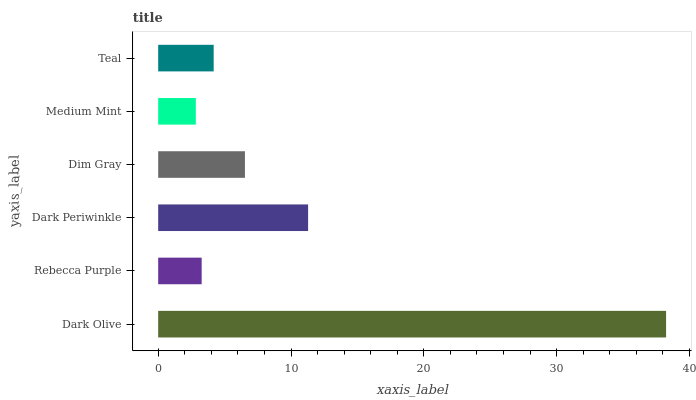Is Medium Mint the minimum?
Answer yes or no. Yes. Is Dark Olive the maximum?
Answer yes or no. Yes. Is Rebecca Purple the minimum?
Answer yes or no. No. Is Rebecca Purple the maximum?
Answer yes or no. No. Is Dark Olive greater than Rebecca Purple?
Answer yes or no. Yes. Is Rebecca Purple less than Dark Olive?
Answer yes or no. Yes. Is Rebecca Purple greater than Dark Olive?
Answer yes or no. No. Is Dark Olive less than Rebecca Purple?
Answer yes or no. No. Is Dim Gray the high median?
Answer yes or no. Yes. Is Teal the low median?
Answer yes or no. Yes. Is Rebecca Purple the high median?
Answer yes or no. No. Is Medium Mint the low median?
Answer yes or no. No. 